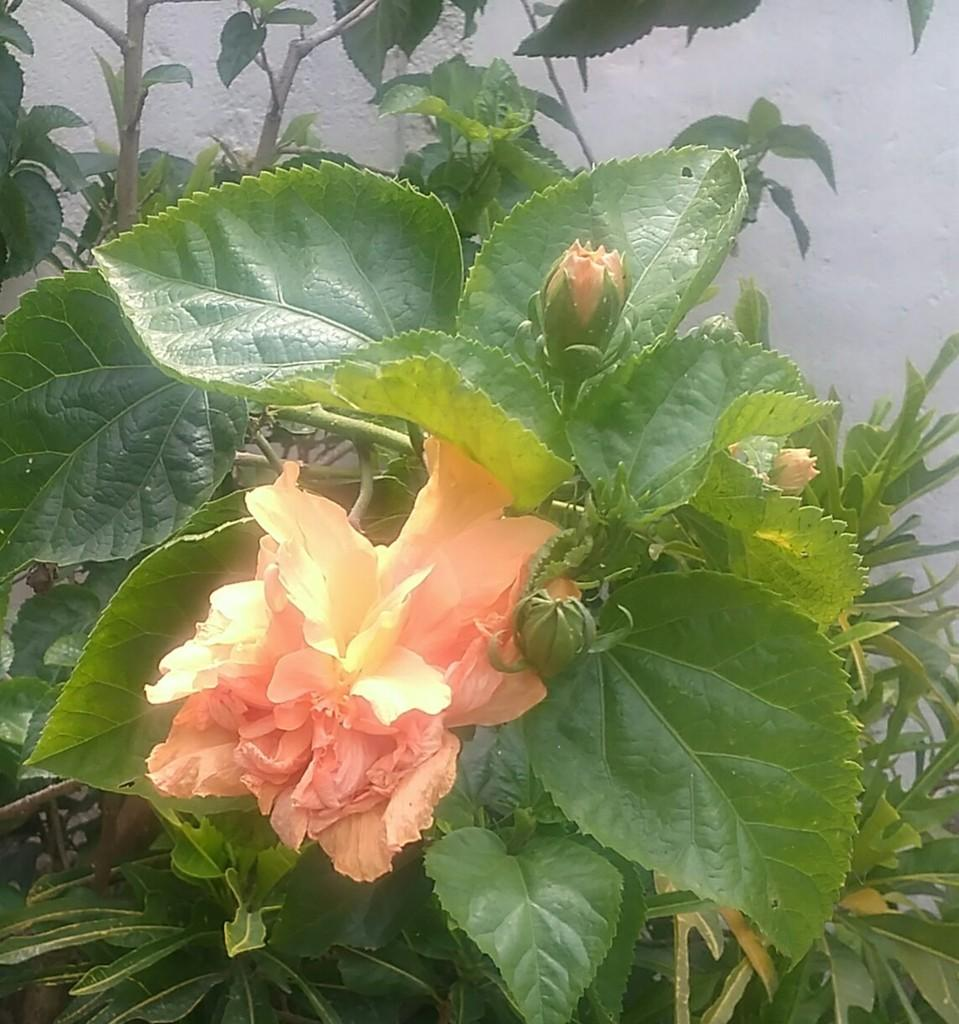What is the main subject of the image? There is a flower in the image. What is the current stage of the plants in the image? There are buds on the plants in the image. What color is the wall visible in the background of the image? There is a white color wall visible in the background of the image. How many jellyfish can be seen swimming near the flower in the image? There are no jellyfish present in the image; it features a flower and plants. What line is visible in the image? There is no line visible in the image; it features a flower, plants, and a white color wall. 